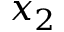<formula> <loc_0><loc_0><loc_500><loc_500>x _ { 2 }</formula> 